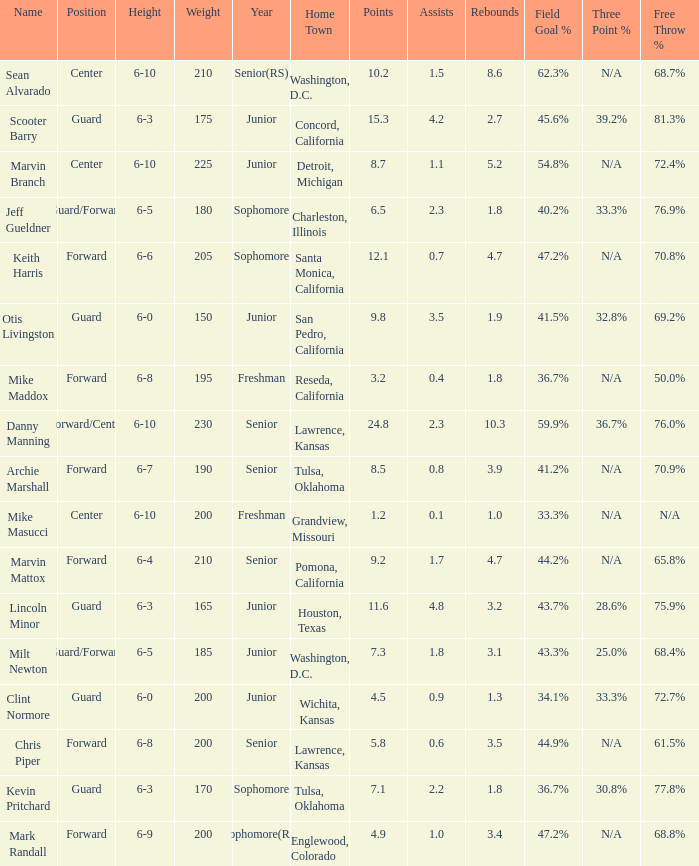Can you tell me the Name that has the Height of 6-5, and the Year of junior? Milt Newton. 